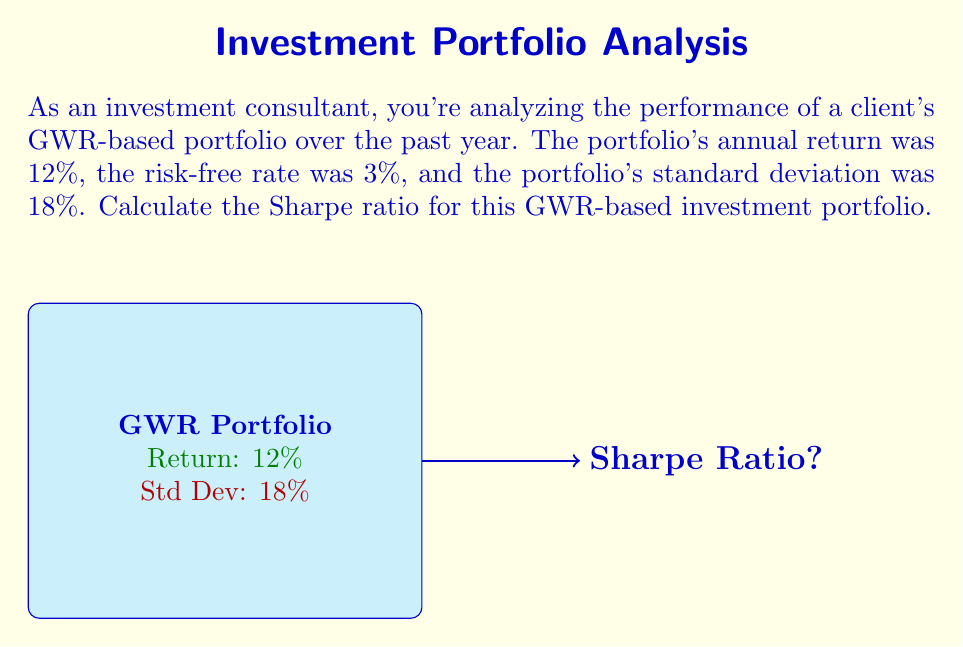Give your solution to this math problem. To calculate the Sharpe ratio, we'll follow these steps:

1) The Sharpe ratio is defined as:

   $$\text{Sharpe Ratio} = \frac{R_p - R_f}{\sigma_p}$$

   Where:
   $R_p$ = Portfolio return
   $R_f$ = Risk-free rate
   $\sigma_p$ = Portfolio standard deviation

2) We're given:
   $R_p = 12\%$ (annual return)
   $R_f = 3\%$ (risk-free rate)
   $\sigma_p = 18\%$ (standard deviation)

3) Let's substitute these values into the formula:

   $$\text{Sharpe Ratio} = \frac{0.12 - 0.03}{0.18}$$

4) First, calculate the numerator:
   
   $$0.12 - 0.03 = 0.09$$

5) Now, divide by the standard deviation:

   $$\frac{0.09}{0.18} = 0.5$$

Therefore, the Sharpe ratio for this GWR-based investment portfolio is 0.5.
Answer: 0.5 